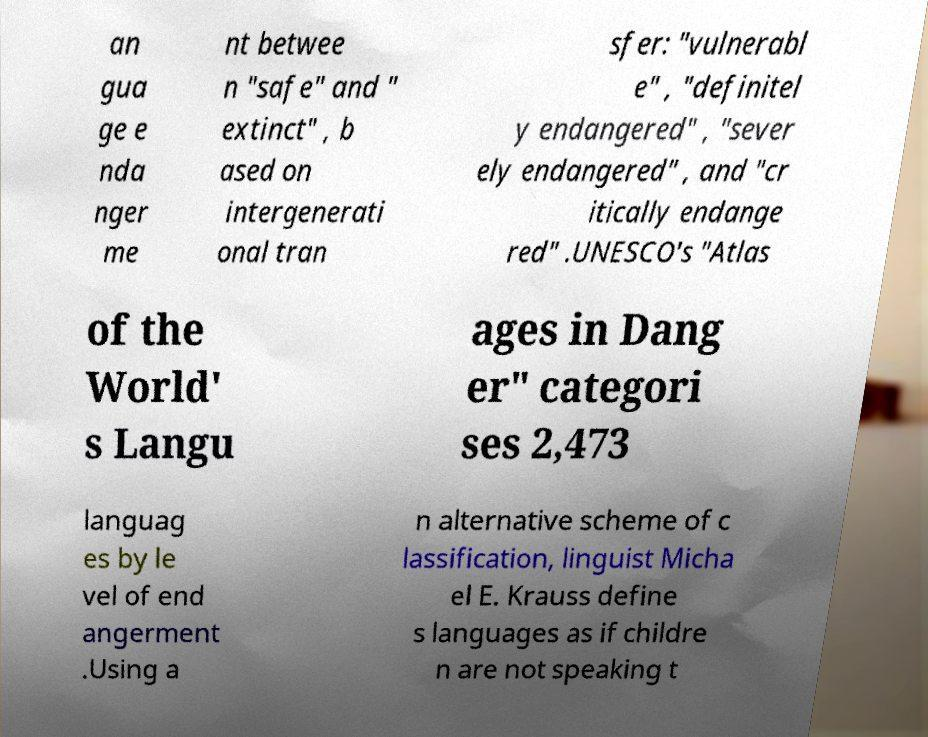For documentation purposes, I need the text within this image transcribed. Could you provide that? an gua ge e nda nger me nt betwee n "safe" and " extinct" , b ased on intergenerati onal tran sfer: "vulnerabl e" , "definitel y endangered" , "sever ely endangered" , and "cr itically endange red" .UNESCO's "Atlas of the World' s Langu ages in Dang er" categori ses 2,473 languag es by le vel of end angerment .Using a n alternative scheme of c lassification, linguist Micha el E. Krauss define s languages as if childre n are not speaking t 